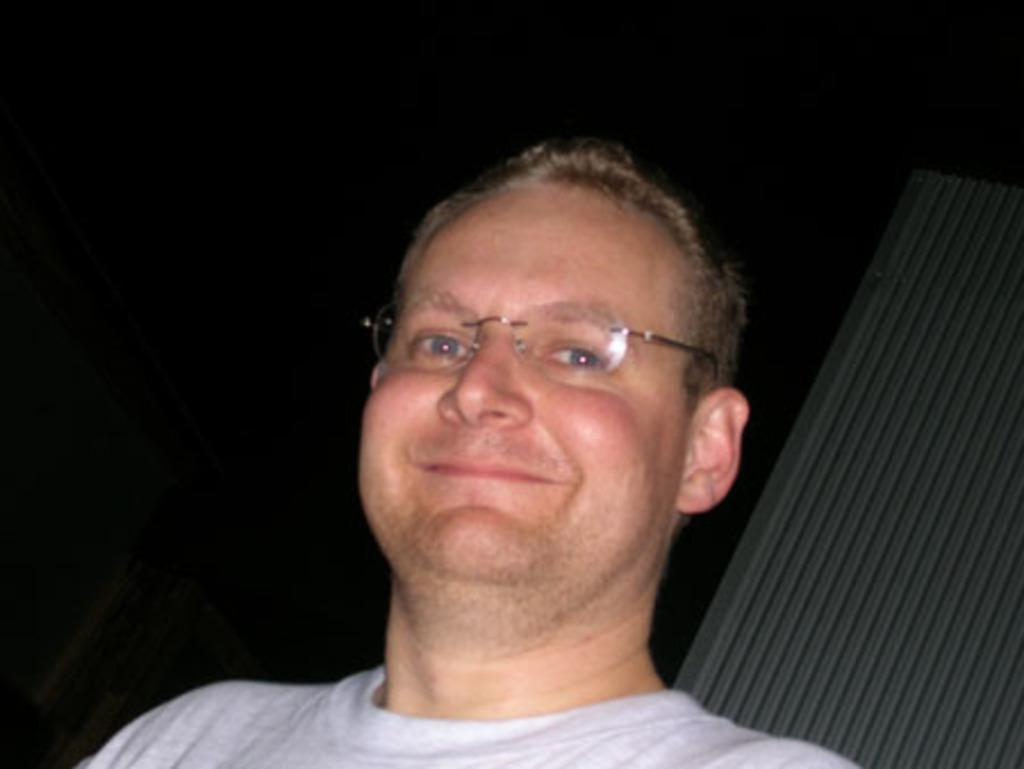Who is the main subject in the image? There is a man in the image. What is the man doing in the image? The man is posing for a photo. Can you describe any accessories the man is wearing? The man is wearing spectacles. What is the color of the background in the image? The background of the image is dark. What type of skin condition can be seen on the man's face in the image? There is no indication of any skin condition on the man's face in the image. Can you tell me what note the man is holding in the image? There is no note present in the image. 